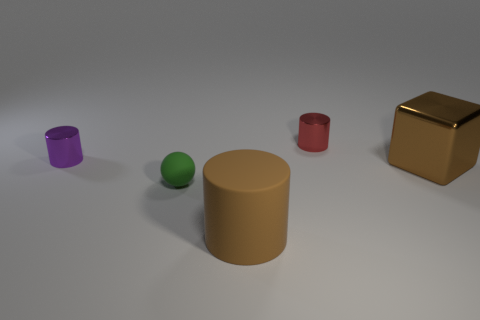How many other things are there of the same material as the big cylinder?
Give a very brief answer. 1. How many other things are the same color as the sphere?
Provide a short and direct response. 0. There is a tiny thing in front of the big brown object right of the red metal cylinder; what is it made of?
Your answer should be compact. Rubber. Are there any tiny things?
Keep it short and to the point. Yes. What size is the metal cylinder that is to the left of the brown object that is left of the brown block?
Provide a short and direct response. Small. Are there more small things left of the tiny red metal object than purple shiny objects that are in front of the big block?
Keep it short and to the point. Yes. What number of cylinders are big brown things or large brown rubber objects?
Keep it short and to the point. 1. There is a shiny object that is on the right side of the red shiny cylinder; does it have the same shape as the green thing?
Your response must be concise. No. The large cube is what color?
Your answer should be compact. Brown. What is the color of the other tiny metallic object that is the same shape as the small red thing?
Ensure brevity in your answer.  Purple. 